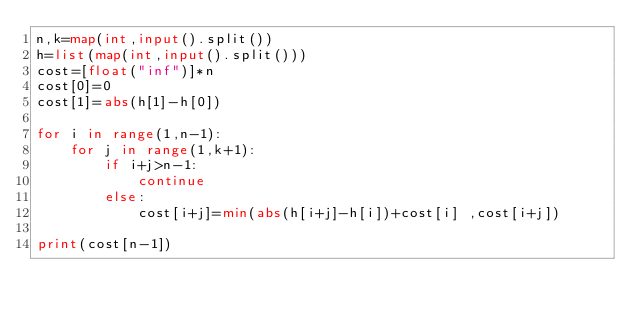Convert code to text. <code><loc_0><loc_0><loc_500><loc_500><_Python_>n,k=map(int,input().split())
h=list(map(int,input().split()))
cost=[float("inf")]*n
cost[0]=0
cost[1]=abs(h[1]-h[0])

for i in range(1,n-1):
    for j in range(1,k+1):
        if i+j>n-1:
            continue
        else:
            cost[i+j]=min(abs(h[i+j]-h[i])+cost[i] ,cost[i+j])

print(cost[n-1])
</code> 